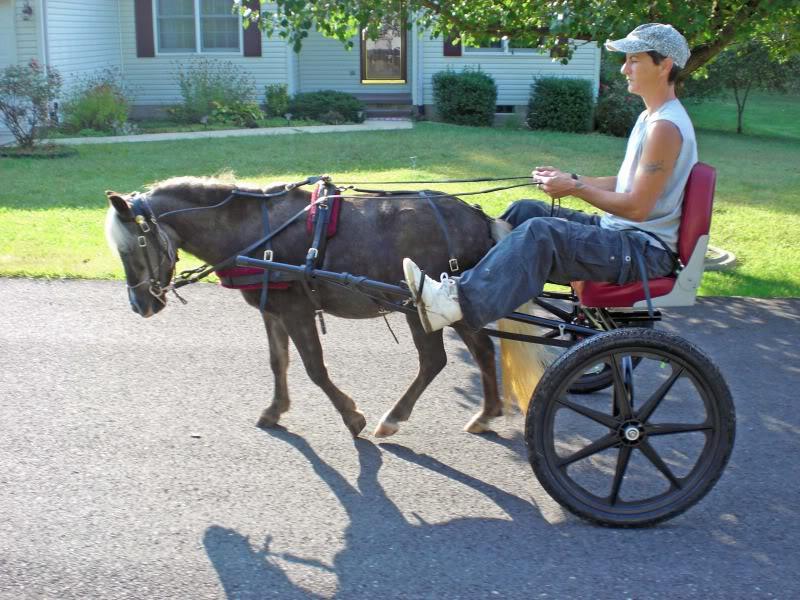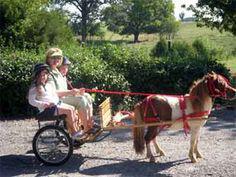The first image is the image on the left, the second image is the image on the right. Examine the images to the left and right. Is the description "Each image depicts one person sitting in a cart pulled by a single pony or horse." accurate? Answer yes or no. No. The first image is the image on the left, the second image is the image on the right. Analyze the images presented: Is the assertion "There are more than two people being pulled by a horse." valid? Answer yes or no. Yes. 